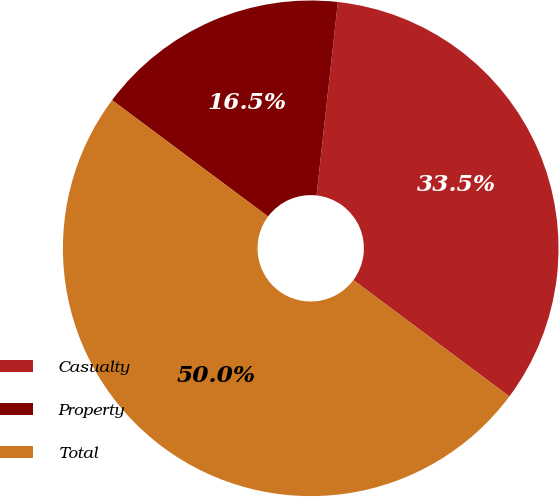<chart> <loc_0><loc_0><loc_500><loc_500><pie_chart><fcel>Casualty<fcel>Property<fcel>Total<nl><fcel>33.45%<fcel>16.55%<fcel>50.0%<nl></chart> 